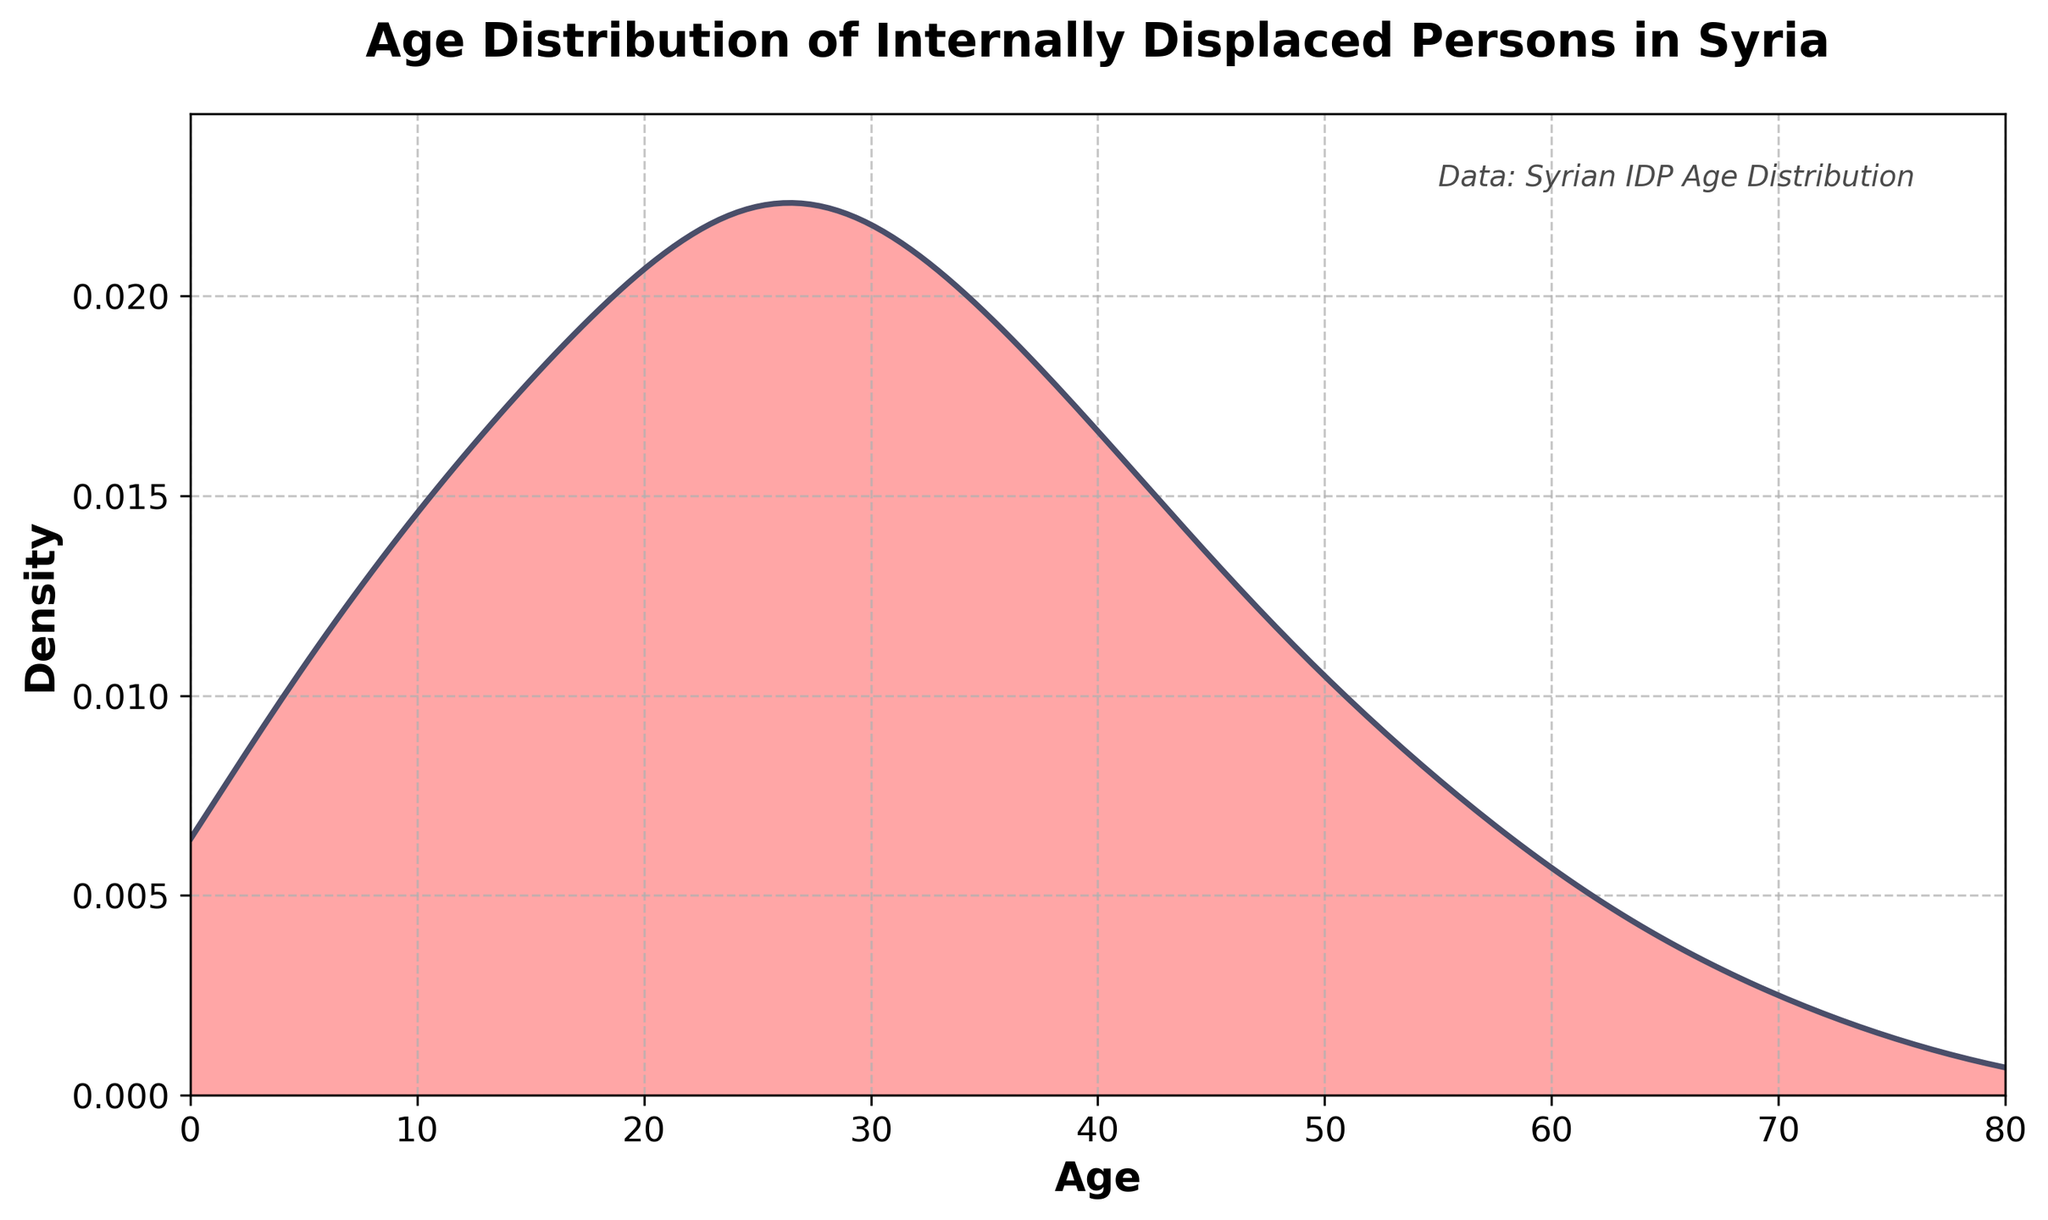How many age categories are shown in the plot? Count the number of different age categories on the x-axis.
Answer: 17 What does the peak in the density plot represent? The peak in the density plot represents the age group with the highest density among the internally displaced persons.
Answer: Age group 25 What can be said about the displacement distribution among elderly (age 60 and above)? Observe the trend in the data for age groups 60 and above and see the density decreases as age increases.
Answer: It decreases Which age groups have a similar density? Compare the density values of different age groups and identify the ranges with similar density values.
Answer: Age groups 35 and 40 What is the general trend of the density as age increases? Look at the overall shape of the density plot from left to right.
Answer: It first increases, reaches a peak, then decreases How does the density of age 55 compare with age 30? Compare the density values at ages 55 and 30 by looking at their heights on the density plot.
Answer: Age 55 density is lower than age 30 What age group is the first to show a decline in density after the initial increase? Identify the age group immediately after which the density starts to decrease.
Answer: Age group 30 Does any age group have a density of zero? Inspect the density values along the plot to see if any point hits the x-axis indicating a density of zero.
Answer: No Which age group marks the beginning of a significant decrease in density? Look for the point where the sharpest decline in density starts after the peak.
Answer: Age group 40 How does the density for age group 45 compare with age group 5? Compare the density values at ages 45 and 5 by looking at their heights on the plot.
Answer: Age group 45 density is higher than age group 5 